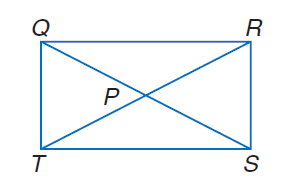Question: Q R S T is a rectangle. If Q P = 3 x + 11 and P S = 4 x + 8, find Q S.
Choices:
A. 10
B. 20
C. 25
D. 40
Answer with the letter. Answer: D 